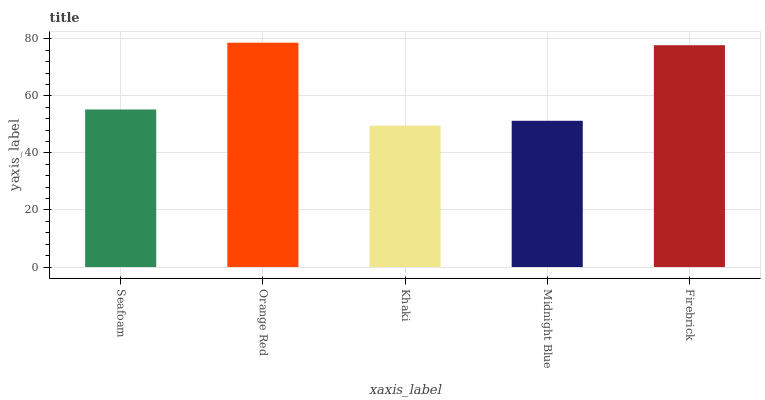Is Khaki the minimum?
Answer yes or no. Yes. Is Orange Red the maximum?
Answer yes or no. Yes. Is Orange Red the minimum?
Answer yes or no. No. Is Khaki the maximum?
Answer yes or no. No. Is Orange Red greater than Khaki?
Answer yes or no. Yes. Is Khaki less than Orange Red?
Answer yes or no. Yes. Is Khaki greater than Orange Red?
Answer yes or no. No. Is Orange Red less than Khaki?
Answer yes or no. No. Is Seafoam the high median?
Answer yes or no. Yes. Is Seafoam the low median?
Answer yes or no. Yes. Is Firebrick the high median?
Answer yes or no. No. Is Firebrick the low median?
Answer yes or no. No. 